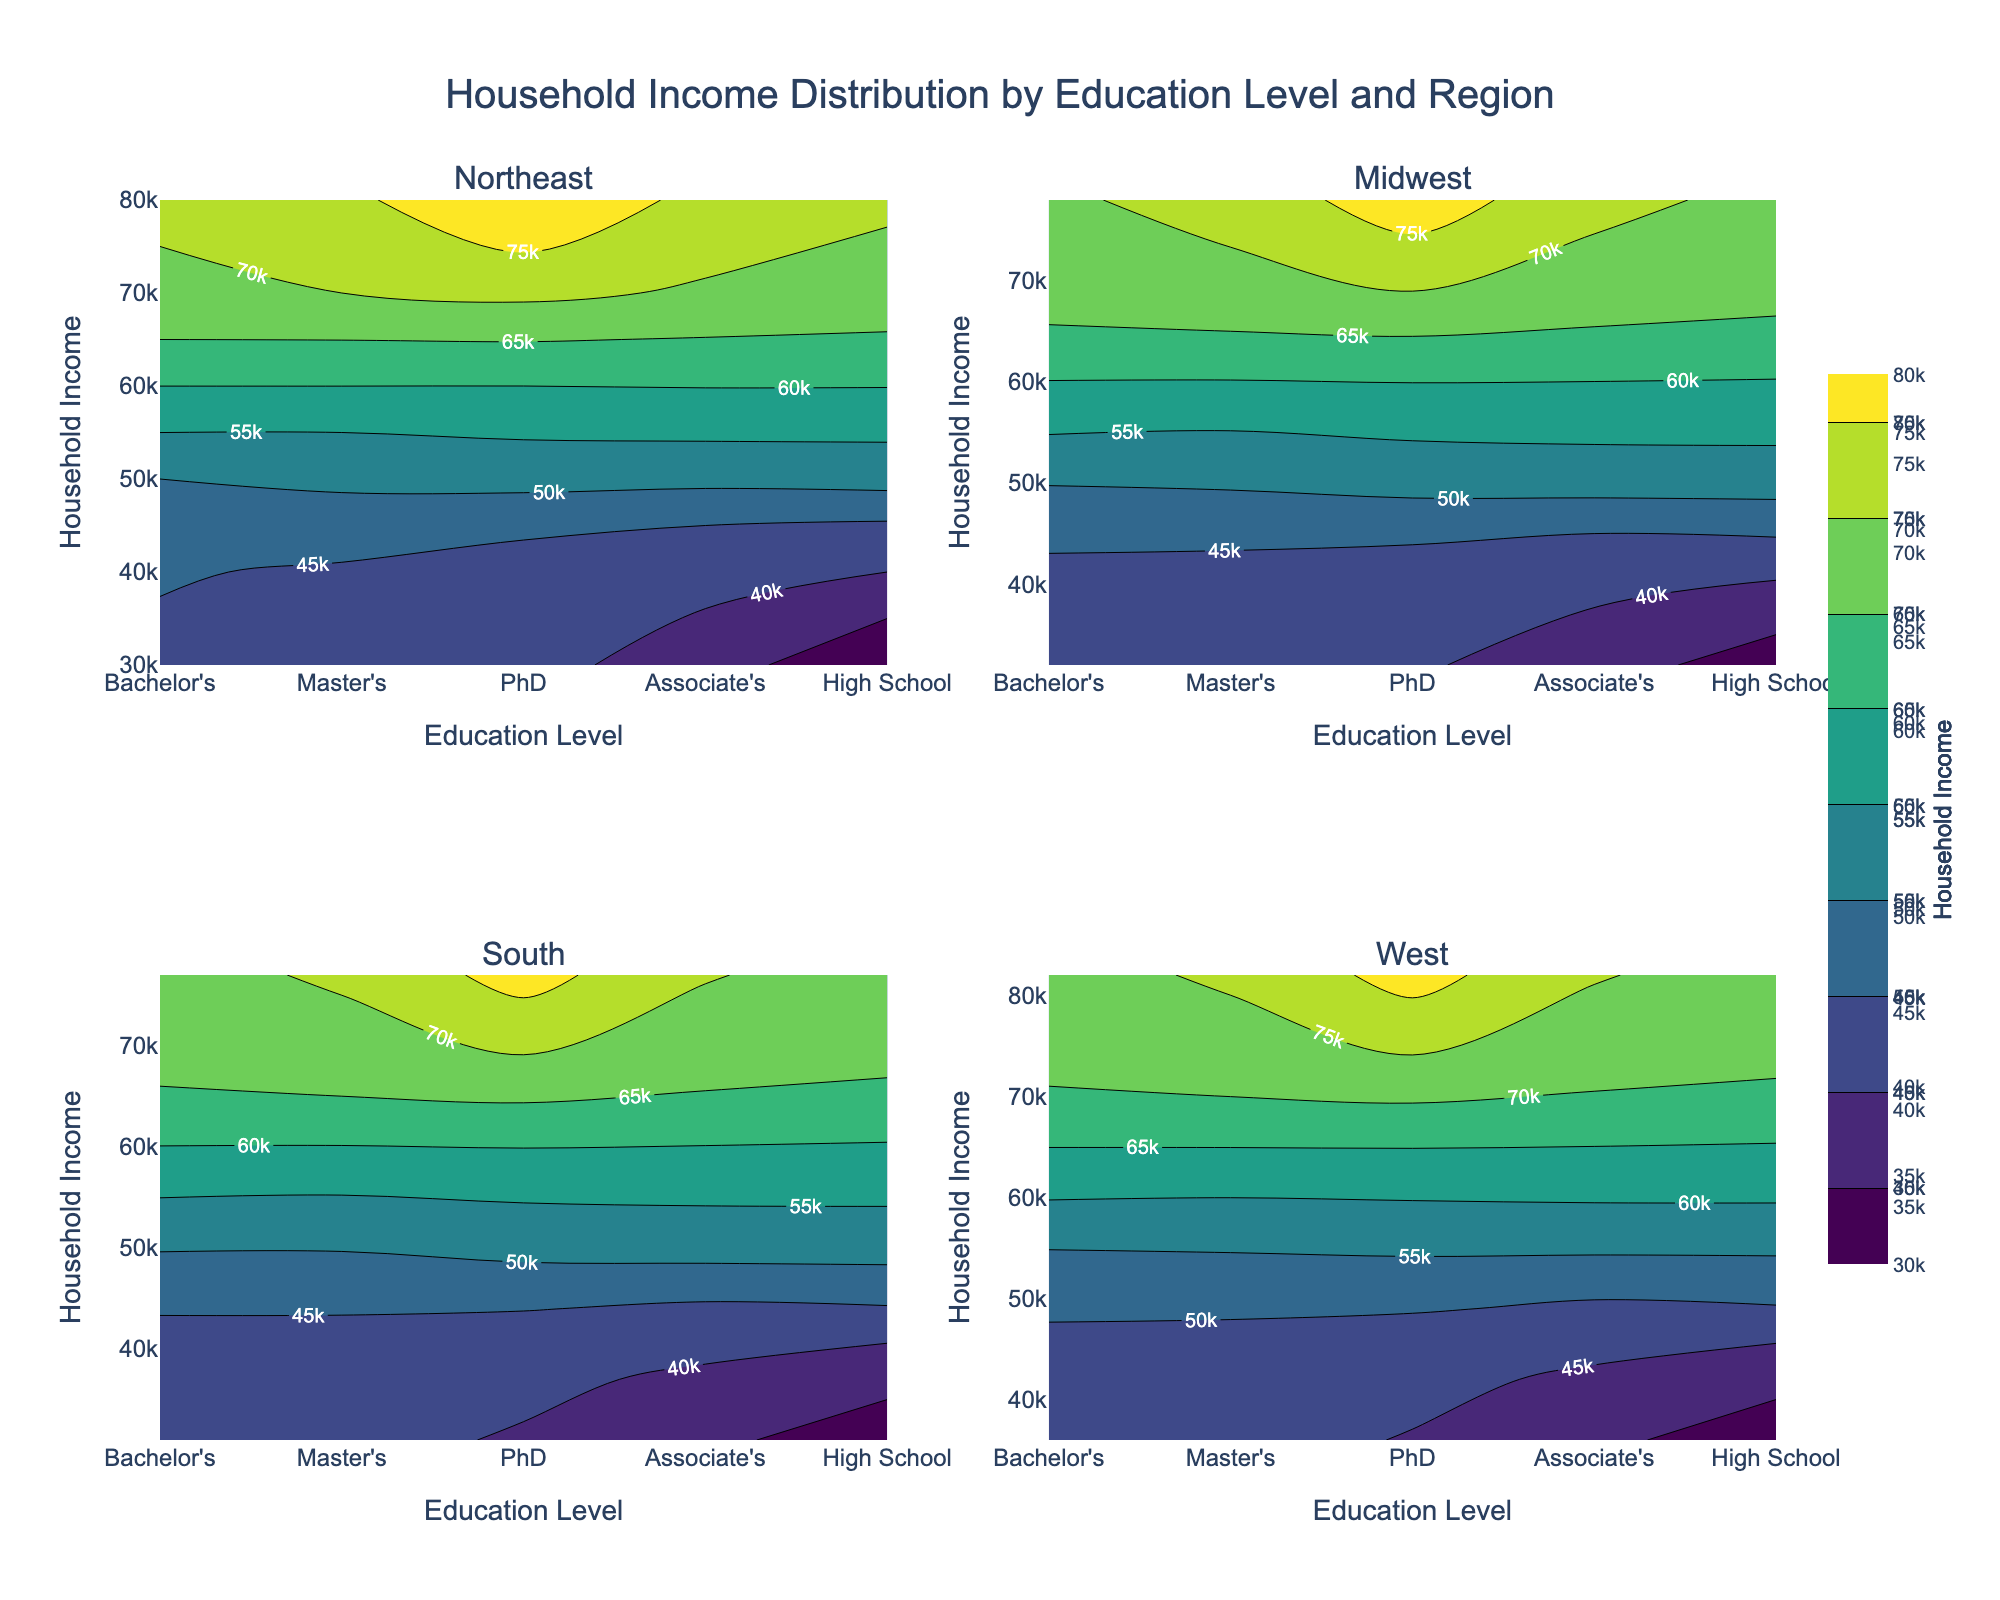What's the title of the figure? The title of the figure is located at the top center and reads, "Household Income Distribution by Education Level and Region."
Answer: Household Income Distribution by Education Level and Region What does the color represent in the contour plots? Each contour plot uses colors to represent the different household income levels, with the scale shown in the color bar on the right.
Answer: Household income levels Which region has the highest household income value? The highest household income value is shown in the West region subplot by the darkest color near the rightmost contour line.
Answer: West What is the education level for the lowest household income in the South region? In the South region subplot, the lowest household income corresponds to the lightest color, which appears at the "High School" education level.
Answer: High School Is there a region where the "Master's" education level has higher household income than the "PhD" level? By comparing the contour plots, the "PhD" level generally has higher household income than the "Master's" level in all regions, without an example contradicting this trend.
Answer: No Which education level generally corresponds to the highest household income across all regions? Across all regions, the "PhD" education level corresponds to the highest household income, as shown by the darkest colors in the contour plots.
Answer: PhD How does the household income at the "Associate's" education level in the Midwest compare to the household income at the "High School" education level in the Northeast? The "Associate's" level in the Midwest has higher household income (darker color) compared to the "High School" level in the Northeast, which is lighter in color.
Answer: Higher Which region's "Bachelor's" education level shows a wider range of household income values? By examining the contour lines' spread at the "Bachelor's" level, the West and Northeast regions both display significant ranges, but the West region shows a slightly wider range of household incomes.
Answer: West Are there any regions where the household income for "High School" and "Associate's" education levels are very close to each other? The contour plots for the Midwest and South regions show that household incomes for "High School" and "Associate's" education levels are quite close, indicated by closely spaced contour lines.
Answer: Midwest, South 